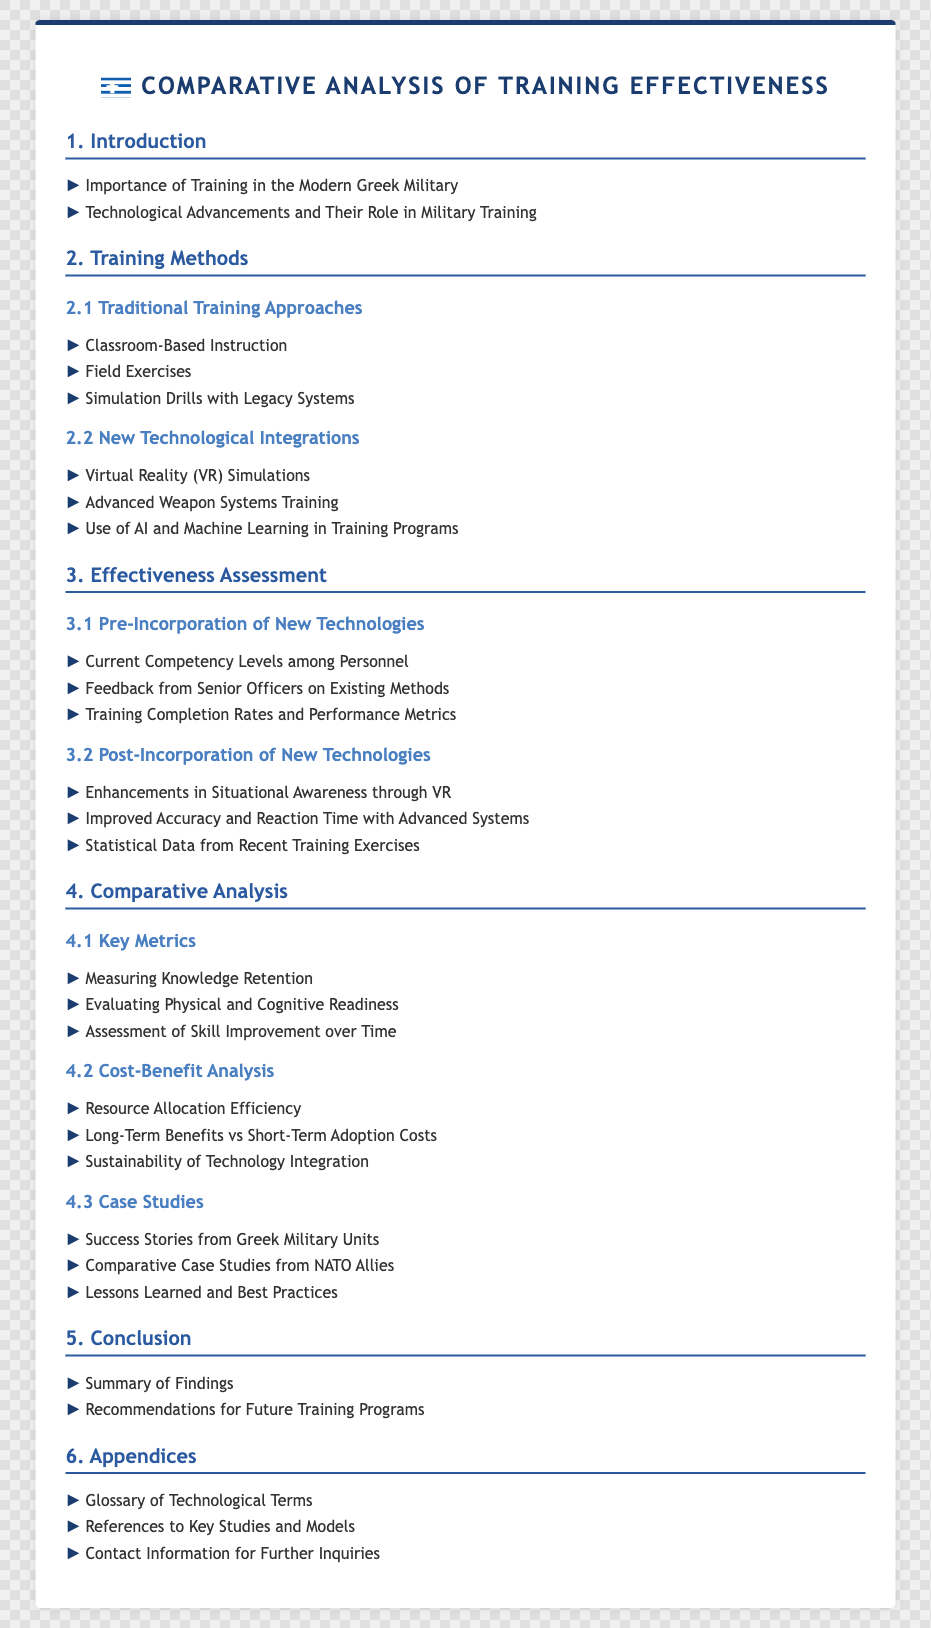What is the title of the document? The title is stated at the top of the document, indicating the main focus.
Answer: Comparative Analysis of Training Effectiveness What section discusses traditional training approaches? This section is explicitly mentioned in the Index under section 2.
Answer: 2.1 Traditional Training Approaches What training method involves VR simulations? This is mentioned in the section on new technological integrations as a modern training approach.
Answer: Virtual Reality (VR) Simulations What is a key metric for assessing training effectiveness? This metric provides insight into personnel's learning retention and is identified in the comparative analysis section.
Answer: Measuring Knowledge Retention What are the long-term benefits mentioned in the cost-benefit analysis? This aspect reflects the outcome of integrating new technologies into training programs.
Answer: Long-Term Benefits vs Short-Term Adoption Costs How many appendices are listed in the document? The count can be determined by reviewing the appendices section of the Index.
Answer: 3 What is a significant aspect of the conclusion section? This indicates the final considerations and recommendations derived from the findings.
Answer: Recommendations for Future Training Programs What type of training method is highlighted in section 3.1? This directly relates to the evaluation of existing training methods before newer systems were introduced.
Answer: Current Competency Levels among Personnel 